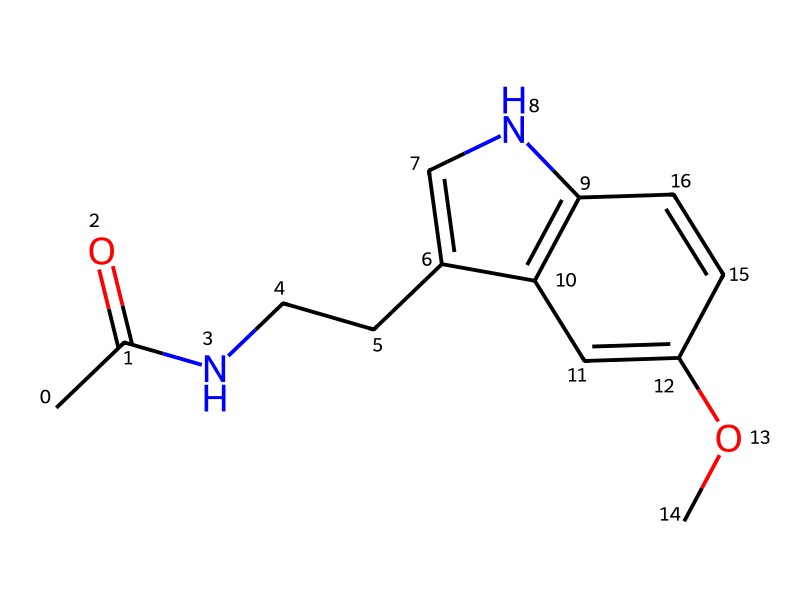What is the chemical name of the compound represented by this SMILES? The SMILES notation corresponds to the molecular structure of melatonin, which is a well-known sleep aid.
Answer: melatonin How many rings are present in the structure? By examining the SMILES, we can identify two ring structures indicated by the numbers '1' and '2', which denotes the beginning and end of each ring in the structure.
Answer: 2 How many nitrogen atoms are in the compound? The structure contains two nitrogen atoms, which can be identified in the molecular structure from the representations within the SMILES.
Answer: 2 What functional group is represented by the "CC(=O)" part in the SMILES? The "CC(=O)" section indicates a carbonyl group (C=O) attached to a carbon chain, which identifies this compound as containing a ketone functional group.
Answer: ketone Is the compound chiral? Yes, this molecule has several stereocenters, which means it can exist in multiple stereoisomeric forms, confirming its chirality.
Answer: Yes What type of compound is melatonin classified as? Melatonin is classified as an indoleamine, which is a sub-class of compounds that include the indole ring structure and an amine functional group.
Answer: indoleamine What effect does the chiral nature of melatonin have on its activity? The chiral nature of melatonin allows for specific interactions with biological receptors, affecting its roles in regulating sleep and circadian rhythms.
Answer: receptor interaction 